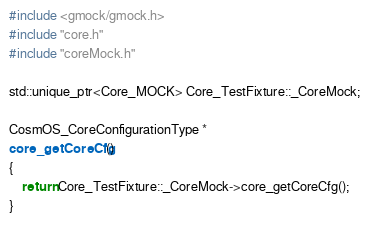Convert code to text. <code><loc_0><loc_0><loc_500><loc_500><_C++_>#include <gmock/gmock.h>
#include "core.h"
#include "coreMock.h"

std::unique_ptr<Core_MOCK> Core_TestFixture::_CoreMock;

CosmOS_CoreConfigurationType *
core_getCoreCfg()
{
    return Core_TestFixture::_CoreMock->core_getCoreCfg();
}
</code> 